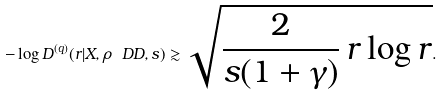Convert formula to latex. <formula><loc_0><loc_0><loc_500><loc_500>- \log D ^ { ( q ) } ( r | X , \rho _ { \ } D D , s ) \gtrsim \sqrt { \frac { 2 } { s ( 1 + \gamma ) } \, r \log r } .</formula> 